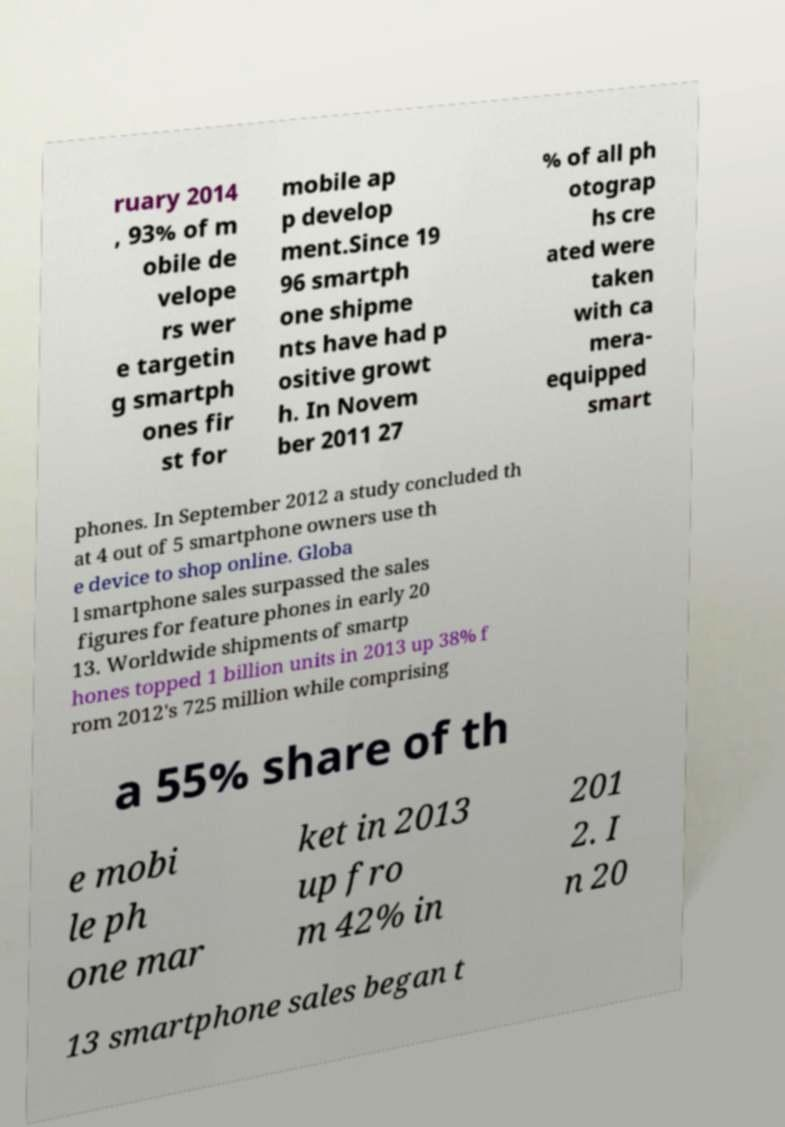I need the written content from this picture converted into text. Can you do that? ruary 2014 , 93% of m obile de velope rs wer e targetin g smartph ones fir st for mobile ap p develop ment.Since 19 96 smartph one shipme nts have had p ositive growt h. In Novem ber 2011 27 % of all ph otograp hs cre ated were taken with ca mera- equipped smart phones. In September 2012 a study concluded th at 4 out of 5 smartphone owners use th e device to shop online. Globa l smartphone sales surpassed the sales figures for feature phones in early 20 13. Worldwide shipments of smartp hones topped 1 billion units in 2013 up 38% f rom 2012's 725 million while comprising a 55% share of th e mobi le ph one mar ket in 2013 up fro m 42% in 201 2. I n 20 13 smartphone sales began t 